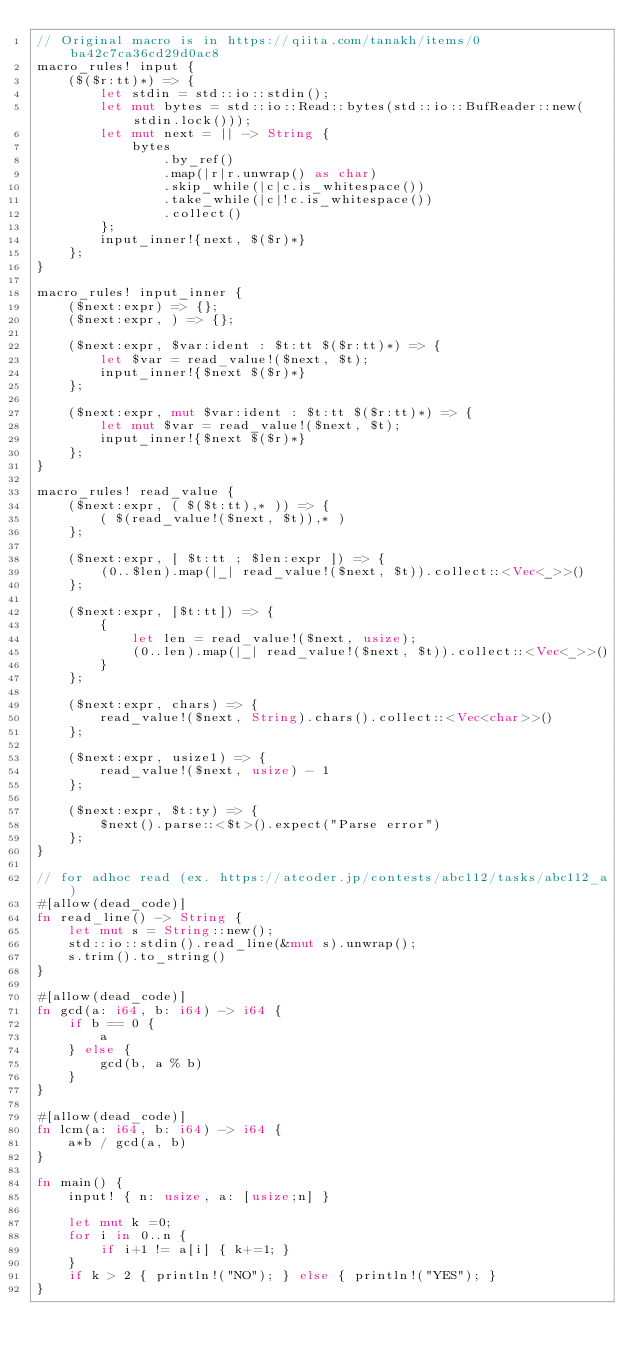Convert code to text. <code><loc_0><loc_0><loc_500><loc_500><_Rust_>// Original macro is in https://qiita.com/tanakh/items/0ba42c7ca36cd29d0ac8
macro_rules! input {
    ($($r:tt)*) => {
        let stdin = std::io::stdin();
        let mut bytes = std::io::Read::bytes(std::io::BufReader::new(stdin.lock()));
        let mut next = || -> String {
            bytes
                .by_ref()
                .map(|r|r.unwrap() as char)
                .skip_while(|c|c.is_whitespace())
                .take_while(|c|!c.is_whitespace())
                .collect()
        };
        input_inner!{next, $($r)*}
    };
}
 
macro_rules! input_inner {
    ($next:expr) => {};
    ($next:expr, ) => {};
 
    ($next:expr, $var:ident : $t:tt $($r:tt)*) => {
        let $var = read_value!($next, $t);
        input_inner!{$next $($r)*}
    };
    
    ($next:expr, mut $var:ident : $t:tt $($r:tt)*) => {
        let mut $var = read_value!($next, $t);
        input_inner!{$next $($r)*}
    };
}
 
macro_rules! read_value {
    ($next:expr, ( $($t:tt),* )) => {
        ( $(read_value!($next, $t)),* )
    };
 
    ($next:expr, [ $t:tt ; $len:expr ]) => {
        (0..$len).map(|_| read_value!($next, $t)).collect::<Vec<_>>()
    };

    ($next:expr, [$t:tt]) => {
        {
            let len = read_value!($next, usize);
            (0..len).map(|_| read_value!($next, $t)).collect::<Vec<_>>()
        }
    };
 
    ($next:expr, chars) => {
        read_value!($next, String).chars().collect::<Vec<char>>()
    };
 
    ($next:expr, usize1) => {
        read_value!($next, usize) - 1
    };
 
    ($next:expr, $t:ty) => {
        $next().parse::<$t>().expect("Parse error")
    };
}

// for adhoc read (ex. https://atcoder.jp/contests/abc112/tasks/abc112_a)
#[allow(dead_code)]
fn read_line() -> String {
    let mut s = String::new();
    std::io::stdin().read_line(&mut s).unwrap();
    s.trim().to_string()
}

#[allow(dead_code)]
fn gcd(a: i64, b: i64) -> i64 {
    if b == 0 {
        a
    } else {
        gcd(b, a % b)
    }
}

#[allow(dead_code)]
fn lcm(a: i64, b: i64) -> i64 {
    a*b / gcd(a, b)
}

fn main() {
    input! { n: usize, a: [usize;n] }

    let mut k =0;
    for i in 0..n {
        if i+1 != a[i] { k+=1; }
    }
    if k > 2 { println!("NO"); } else { println!("YES"); }
}
</code> 